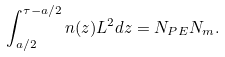<formula> <loc_0><loc_0><loc_500><loc_500>\int ^ { \tau - a / 2 } _ { a / 2 } n ( z ) L ^ { 2 } d z = N _ { P E } N _ { m } .</formula> 